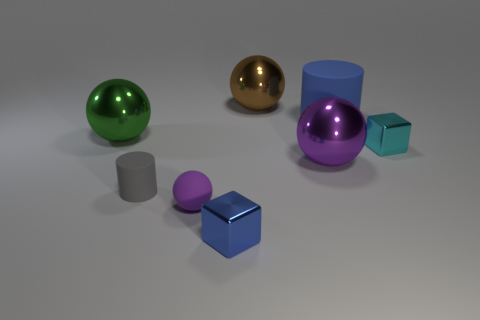The green metal object that is the same shape as the tiny purple thing is what size?
Your response must be concise. Large. Are there any other things that have the same size as the gray matte thing?
Make the answer very short. Yes. There is a purple ball behind the rubber cylinder that is in front of the blue rubber object; what is it made of?
Offer a very short reply. Metal. Is the shape of the large purple metallic thing the same as the brown shiny object?
Offer a very short reply. Yes. What number of blue objects are behind the small purple rubber thing and in front of the large green object?
Provide a short and direct response. 0. Are there the same number of big purple things that are on the left side of the gray object and large blue rubber objects to the left of the purple matte thing?
Provide a short and direct response. Yes. There is a metallic sphere in front of the small cyan cube; does it have the same size as the rubber cylinder on the left side of the big brown sphere?
Your answer should be very brief. No. What is the object that is both behind the green object and to the left of the big blue object made of?
Offer a very short reply. Metal. Is the number of red matte blocks less than the number of big purple spheres?
Make the answer very short. Yes. There is a matte object behind the big metal object that is left of the small blue metallic cube; what is its size?
Provide a succinct answer. Large. 